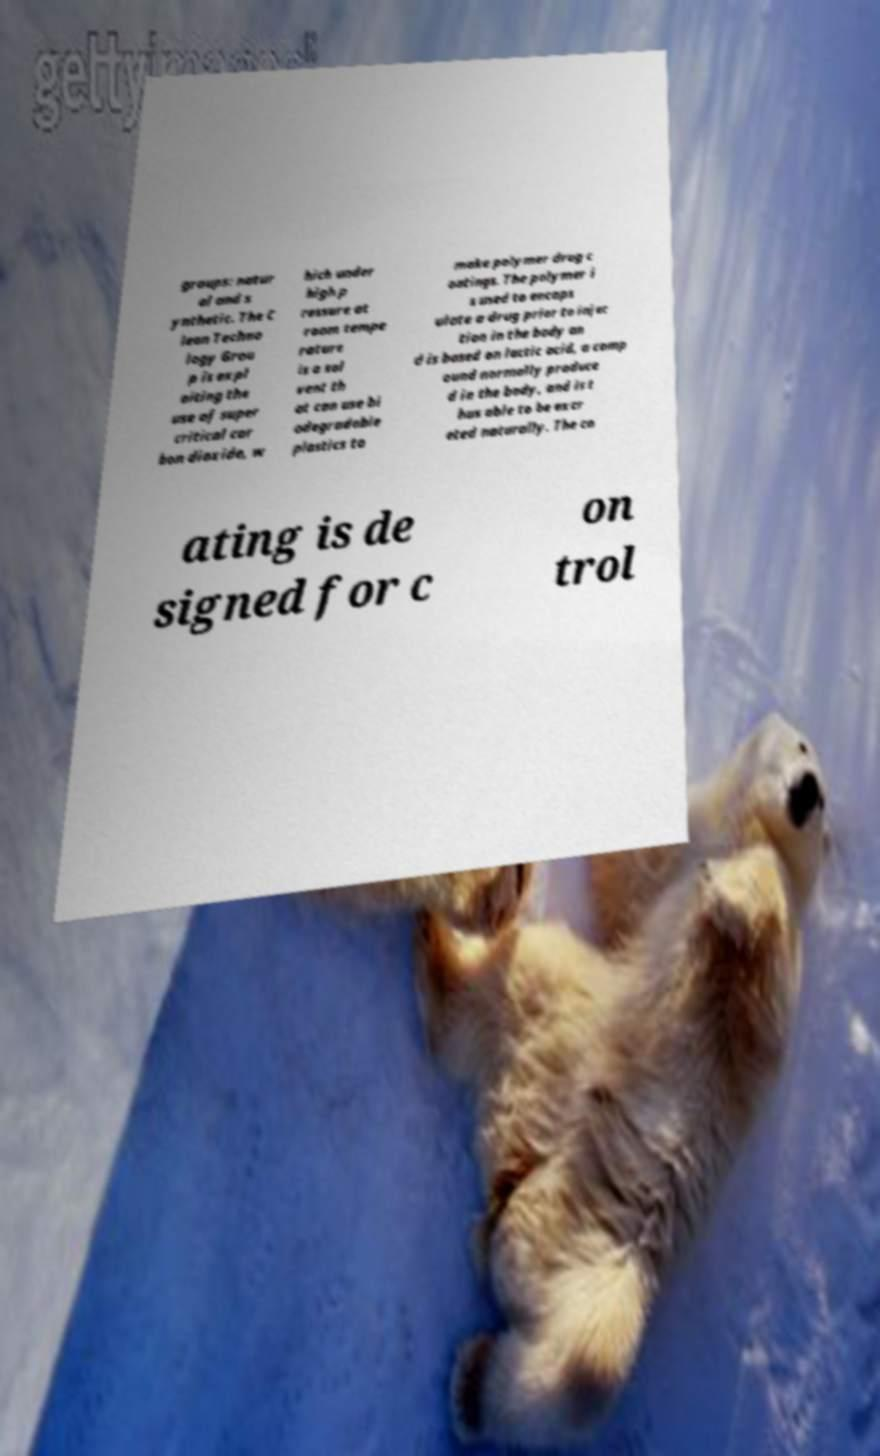I need the written content from this picture converted into text. Can you do that? groups: natur al and s ynthetic. The C lean Techno logy Grou p is expl oiting the use of super critical car bon dioxide, w hich under high p ressure at room tempe rature is a sol vent th at can use bi odegradable plastics to make polymer drug c oatings. The polymer i s used to encaps ulate a drug prior to injec tion in the body an d is based on lactic acid, a comp ound normally produce d in the body, and is t hus able to be excr eted naturally. The co ating is de signed for c on trol 